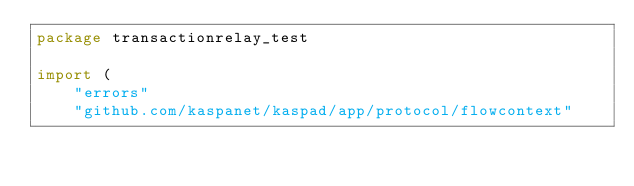<code> <loc_0><loc_0><loc_500><loc_500><_Go_>package transactionrelay_test

import (
	"errors"
	"github.com/kaspanet/kaspad/app/protocol/flowcontext"</code> 